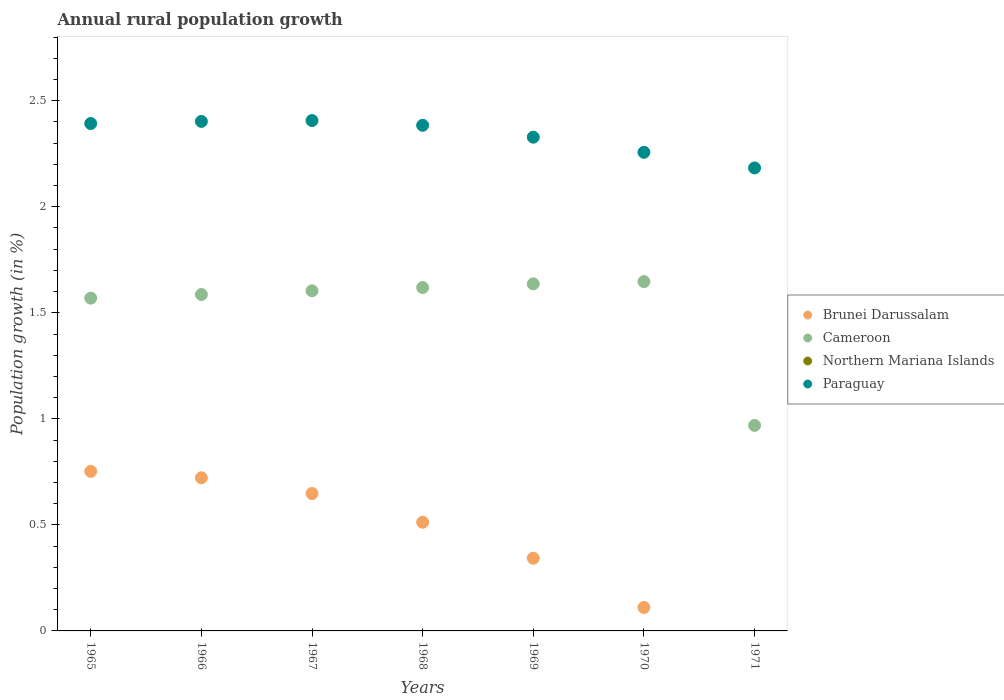How many different coloured dotlines are there?
Make the answer very short. 3. Is the number of dotlines equal to the number of legend labels?
Make the answer very short. No. What is the percentage of rural population growth in Northern Mariana Islands in 1968?
Ensure brevity in your answer.  0. Across all years, what is the maximum percentage of rural population growth in Paraguay?
Your answer should be very brief. 2.41. Across all years, what is the minimum percentage of rural population growth in Cameroon?
Give a very brief answer. 0.97. In which year was the percentage of rural population growth in Paraguay maximum?
Ensure brevity in your answer.  1967. What is the total percentage of rural population growth in Paraguay in the graph?
Ensure brevity in your answer.  16.35. What is the difference between the percentage of rural population growth in Paraguay in 1965 and that in 1971?
Keep it short and to the point. 0.21. What is the difference between the percentage of rural population growth in Paraguay in 1966 and the percentage of rural population growth in Northern Mariana Islands in 1968?
Provide a short and direct response. 2.4. What is the average percentage of rural population growth in Brunei Darussalam per year?
Your answer should be compact. 0.44. In the year 1969, what is the difference between the percentage of rural population growth in Brunei Darussalam and percentage of rural population growth in Cameroon?
Provide a succinct answer. -1.29. In how many years, is the percentage of rural population growth in Northern Mariana Islands greater than 1.7 %?
Give a very brief answer. 0. What is the ratio of the percentage of rural population growth in Paraguay in 1966 to that in 1970?
Keep it short and to the point. 1.06. Is the difference between the percentage of rural population growth in Brunei Darussalam in 1966 and 1970 greater than the difference between the percentage of rural population growth in Cameroon in 1966 and 1970?
Your answer should be very brief. Yes. What is the difference between the highest and the second highest percentage of rural population growth in Paraguay?
Provide a succinct answer. 0. What is the difference between the highest and the lowest percentage of rural population growth in Cameroon?
Your answer should be compact. 0.68. In how many years, is the percentage of rural population growth in Northern Mariana Islands greater than the average percentage of rural population growth in Northern Mariana Islands taken over all years?
Your answer should be compact. 0. Is the sum of the percentage of rural population growth in Paraguay in 1968 and 1971 greater than the maximum percentage of rural population growth in Northern Mariana Islands across all years?
Your response must be concise. Yes. Is it the case that in every year, the sum of the percentage of rural population growth in Brunei Darussalam and percentage of rural population growth in Paraguay  is greater than the sum of percentage of rural population growth in Northern Mariana Islands and percentage of rural population growth in Cameroon?
Ensure brevity in your answer.  No. Is it the case that in every year, the sum of the percentage of rural population growth in Brunei Darussalam and percentage of rural population growth in Paraguay  is greater than the percentage of rural population growth in Cameroon?
Make the answer very short. Yes. Is the percentage of rural population growth in Northern Mariana Islands strictly less than the percentage of rural population growth in Paraguay over the years?
Your answer should be compact. Yes. How many dotlines are there?
Your response must be concise. 3. How many years are there in the graph?
Your response must be concise. 7. What is the difference between two consecutive major ticks on the Y-axis?
Give a very brief answer. 0.5. Are the values on the major ticks of Y-axis written in scientific E-notation?
Offer a terse response. No. Does the graph contain any zero values?
Ensure brevity in your answer.  Yes. Does the graph contain grids?
Ensure brevity in your answer.  No. Where does the legend appear in the graph?
Make the answer very short. Center right. How many legend labels are there?
Provide a succinct answer. 4. How are the legend labels stacked?
Offer a very short reply. Vertical. What is the title of the graph?
Your response must be concise. Annual rural population growth. What is the label or title of the Y-axis?
Provide a short and direct response. Population growth (in %). What is the Population growth (in %) in Brunei Darussalam in 1965?
Your answer should be very brief. 0.75. What is the Population growth (in %) of Cameroon in 1965?
Provide a succinct answer. 1.57. What is the Population growth (in %) in Northern Mariana Islands in 1965?
Offer a terse response. 0. What is the Population growth (in %) of Paraguay in 1965?
Keep it short and to the point. 2.39. What is the Population growth (in %) in Brunei Darussalam in 1966?
Make the answer very short. 0.72. What is the Population growth (in %) of Cameroon in 1966?
Keep it short and to the point. 1.59. What is the Population growth (in %) in Paraguay in 1966?
Your response must be concise. 2.4. What is the Population growth (in %) in Brunei Darussalam in 1967?
Offer a terse response. 0.65. What is the Population growth (in %) in Cameroon in 1967?
Provide a succinct answer. 1.6. What is the Population growth (in %) in Paraguay in 1967?
Offer a terse response. 2.41. What is the Population growth (in %) in Brunei Darussalam in 1968?
Offer a terse response. 0.51. What is the Population growth (in %) in Cameroon in 1968?
Your response must be concise. 1.62. What is the Population growth (in %) of Paraguay in 1968?
Offer a terse response. 2.38. What is the Population growth (in %) of Brunei Darussalam in 1969?
Your answer should be compact. 0.34. What is the Population growth (in %) of Cameroon in 1969?
Offer a terse response. 1.64. What is the Population growth (in %) of Paraguay in 1969?
Keep it short and to the point. 2.33. What is the Population growth (in %) of Brunei Darussalam in 1970?
Provide a succinct answer. 0.11. What is the Population growth (in %) of Cameroon in 1970?
Give a very brief answer. 1.65. What is the Population growth (in %) in Paraguay in 1970?
Provide a short and direct response. 2.26. What is the Population growth (in %) in Cameroon in 1971?
Your answer should be very brief. 0.97. What is the Population growth (in %) of Paraguay in 1971?
Your answer should be compact. 2.18. Across all years, what is the maximum Population growth (in %) in Brunei Darussalam?
Provide a short and direct response. 0.75. Across all years, what is the maximum Population growth (in %) of Cameroon?
Offer a very short reply. 1.65. Across all years, what is the maximum Population growth (in %) in Paraguay?
Provide a succinct answer. 2.41. Across all years, what is the minimum Population growth (in %) of Cameroon?
Your answer should be very brief. 0.97. Across all years, what is the minimum Population growth (in %) of Paraguay?
Your response must be concise. 2.18. What is the total Population growth (in %) in Brunei Darussalam in the graph?
Offer a terse response. 3.09. What is the total Population growth (in %) of Cameroon in the graph?
Provide a succinct answer. 10.63. What is the total Population growth (in %) of Paraguay in the graph?
Offer a terse response. 16.35. What is the difference between the Population growth (in %) in Brunei Darussalam in 1965 and that in 1966?
Provide a short and direct response. 0.03. What is the difference between the Population growth (in %) in Cameroon in 1965 and that in 1966?
Provide a short and direct response. -0.02. What is the difference between the Population growth (in %) of Paraguay in 1965 and that in 1966?
Make the answer very short. -0.01. What is the difference between the Population growth (in %) of Brunei Darussalam in 1965 and that in 1967?
Offer a terse response. 0.1. What is the difference between the Population growth (in %) of Cameroon in 1965 and that in 1967?
Offer a terse response. -0.03. What is the difference between the Population growth (in %) of Paraguay in 1965 and that in 1967?
Your answer should be very brief. -0.01. What is the difference between the Population growth (in %) of Brunei Darussalam in 1965 and that in 1968?
Ensure brevity in your answer.  0.24. What is the difference between the Population growth (in %) of Cameroon in 1965 and that in 1968?
Ensure brevity in your answer.  -0.05. What is the difference between the Population growth (in %) of Paraguay in 1965 and that in 1968?
Provide a succinct answer. 0.01. What is the difference between the Population growth (in %) in Brunei Darussalam in 1965 and that in 1969?
Provide a succinct answer. 0.41. What is the difference between the Population growth (in %) in Cameroon in 1965 and that in 1969?
Your response must be concise. -0.07. What is the difference between the Population growth (in %) of Paraguay in 1965 and that in 1969?
Your response must be concise. 0.06. What is the difference between the Population growth (in %) in Brunei Darussalam in 1965 and that in 1970?
Your answer should be compact. 0.64. What is the difference between the Population growth (in %) in Cameroon in 1965 and that in 1970?
Provide a succinct answer. -0.08. What is the difference between the Population growth (in %) of Paraguay in 1965 and that in 1970?
Provide a short and direct response. 0.14. What is the difference between the Population growth (in %) of Cameroon in 1965 and that in 1971?
Your response must be concise. 0.6. What is the difference between the Population growth (in %) of Paraguay in 1965 and that in 1971?
Provide a succinct answer. 0.21. What is the difference between the Population growth (in %) in Brunei Darussalam in 1966 and that in 1967?
Make the answer very short. 0.07. What is the difference between the Population growth (in %) in Cameroon in 1966 and that in 1967?
Offer a terse response. -0.02. What is the difference between the Population growth (in %) of Paraguay in 1966 and that in 1967?
Your answer should be very brief. -0. What is the difference between the Population growth (in %) of Brunei Darussalam in 1966 and that in 1968?
Your answer should be compact. 0.21. What is the difference between the Population growth (in %) of Cameroon in 1966 and that in 1968?
Keep it short and to the point. -0.03. What is the difference between the Population growth (in %) in Paraguay in 1966 and that in 1968?
Keep it short and to the point. 0.02. What is the difference between the Population growth (in %) of Brunei Darussalam in 1966 and that in 1969?
Offer a very short reply. 0.38. What is the difference between the Population growth (in %) in Cameroon in 1966 and that in 1969?
Your answer should be compact. -0.05. What is the difference between the Population growth (in %) in Paraguay in 1966 and that in 1969?
Your response must be concise. 0.07. What is the difference between the Population growth (in %) in Brunei Darussalam in 1966 and that in 1970?
Provide a short and direct response. 0.61. What is the difference between the Population growth (in %) of Cameroon in 1966 and that in 1970?
Give a very brief answer. -0.06. What is the difference between the Population growth (in %) of Paraguay in 1966 and that in 1970?
Your answer should be very brief. 0.15. What is the difference between the Population growth (in %) of Cameroon in 1966 and that in 1971?
Make the answer very short. 0.62. What is the difference between the Population growth (in %) of Paraguay in 1966 and that in 1971?
Your answer should be very brief. 0.22. What is the difference between the Population growth (in %) of Brunei Darussalam in 1967 and that in 1968?
Provide a short and direct response. 0.14. What is the difference between the Population growth (in %) in Cameroon in 1967 and that in 1968?
Give a very brief answer. -0.02. What is the difference between the Population growth (in %) of Paraguay in 1967 and that in 1968?
Offer a terse response. 0.02. What is the difference between the Population growth (in %) of Brunei Darussalam in 1967 and that in 1969?
Provide a succinct answer. 0.3. What is the difference between the Population growth (in %) in Cameroon in 1967 and that in 1969?
Ensure brevity in your answer.  -0.03. What is the difference between the Population growth (in %) of Paraguay in 1967 and that in 1969?
Give a very brief answer. 0.08. What is the difference between the Population growth (in %) in Brunei Darussalam in 1967 and that in 1970?
Provide a short and direct response. 0.54. What is the difference between the Population growth (in %) in Cameroon in 1967 and that in 1970?
Provide a succinct answer. -0.04. What is the difference between the Population growth (in %) in Paraguay in 1967 and that in 1970?
Your answer should be very brief. 0.15. What is the difference between the Population growth (in %) in Cameroon in 1967 and that in 1971?
Make the answer very short. 0.63. What is the difference between the Population growth (in %) of Paraguay in 1967 and that in 1971?
Offer a terse response. 0.22. What is the difference between the Population growth (in %) of Brunei Darussalam in 1968 and that in 1969?
Ensure brevity in your answer.  0.17. What is the difference between the Population growth (in %) in Cameroon in 1968 and that in 1969?
Make the answer very short. -0.02. What is the difference between the Population growth (in %) in Paraguay in 1968 and that in 1969?
Your response must be concise. 0.06. What is the difference between the Population growth (in %) in Brunei Darussalam in 1968 and that in 1970?
Offer a very short reply. 0.4. What is the difference between the Population growth (in %) of Cameroon in 1968 and that in 1970?
Provide a succinct answer. -0.03. What is the difference between the Population growth (in %) of Paraguay in 1968 and that in 1970?
Your answer should be very brief. 0.13. What is the difference between the Population growth (in %) in Cameroon in 1968 and that in 1971?
Keep it short and to the point. 0.65. What is the difference between the Population growth (in %) in Paraguay in 1968 and that in 1971?
Ensure brevity in your answer.  0.2. What is the difference between the Population growth (in %) in Brunei Darussalam in 1969 and that in 1970?
Give a very brief answer. 0.23. What is the difference between the Population growth (in %) in Cameroon in 1969 and that in 1970?
Your answer should be very brief. -0.01. What is the difference between the Population growth (in %) of Paraguay in 1969 and that in 1970?
Your answer should be very brief. 0.07. What is the difference between the Population growth (in %) of Cameroon in 1969 and that in 1971?
Keep it short and to the point. 0.67. What is the difference between the Population growth (in %) of Paraguay in 1969 and that in 1971?
Give a very brief answer. 0.14. What is the difference between the Population growth (in %) in Cameroon in 1970 and that in 1971?
Ensure brevity in your answer.  0.68. What is the difference between the Population growth (in %) of Paraguay in 1970 and that in 1971?
Provide a succinct answer. 0.07. What is the difference between the Population growth (in %) in Brunei Darussalam in 1965 and the Population growth (in %) in Cameroon in 1966?
Give a very brief answer. -0.83. What is the difference between the Population growth (in %) in Brunei Darussalam in 1965 and the Population growth (in %) in Paraguay in 1966?
Provide a succinct answer. -1.65. What is the difference between the Population growth (in %) in Cameroon in 1965 and the Population growth (in %) in Paraguay in 1966?
Keep it short and to the point. -0.83. What is the difference between the Population growth (in %) of Brunei Darussalam in 1965 and the Population growth (in %) of Cameroon in 1967?
Give a very brief answer. -0.85. What is the difference between the Population growth (in %) of Brunei Darussalam in 1965 and the Population growth (in %) of Paraguay in 1967?
Offer a terse response. -1.65. What is the difference between the Population growth (in %) of Cameroon in 1965 and the Population growth (in %) of Paraguay in 1967?
Provide a short and direct response. -0.84. What is the difference between the Population growth (in %) of Brunei Darussalam in 1965 and the Population growth (in %) of Cameroon in 1968?
Your response must be concise. -0.87. What is the difference between the Population growth (in %) of Brunei Darussalam in 1965 and the Population growth (in %) of Paraguay in 1968?
Make the answer very short. -1.63. What is the difference between the Population growth (in %) of Cameroon in 1965 and the Population growth (in %) of Paraguay in 1968?
Offer a very short reply. -0.81. What is the difference between the Population growth (in %) of Brunei Darussalam in 1965 and the Population growth (in %) of Cameroon in 1969?
Your answer should be very brief. -0.88. What is the difference between the Population growth (in %) in Brunei Darussalam in 1965 and the Population growth (in %) in Paraguay in 1969?
Provide a short and direct response. -1.58. What is the difference between the Population growth (in %) of Cameroon in 1965 and the Population growth (in %) of Paraguay in 1969?
Your answer should be compact. -0.76. What is the difference between the Population growth (in %) in Brunei Darussalam in 1965 and the Population growth (in %) in Cameroon in 1970?
Provide a succinct answer. -0.89. What is the difference between the Population growth (in %) in Brunei Darussalam in 1965 and the Population growth (in %) in Paraguay in 1970?
Your answer should be very brief. -1.5. What is the difference between the Population growth (in %) of Cameroon in 1965 and the Population growth (in %) of Paraguay in 1970?
Offer a terse response. -0.69. What is the difference between the Population growth (in %) in Brunei Darussalam in 1965 and the Population growth (in %) in Cameroon in 1971?
Provide a short and direct response. -0.22. What is the difference between the Population growth (in %) of Brunei Darussalam in 1965 and the Population growth (in %) of Paraguay in 1971?
Your answer should be very brief. -1.43. What is the difference between the Population growth (in %) in Cameroon in 1965 and the Population growth (in %) in Paraguay in 1971?
Your answer should be compact. -0.61. What is the difference between the Population growth (in %) in Brunei Darussalam in 1966 and the Population growth (in %) in Cameroon in 1967?
Offer a very short reply. -0.88. What is the difference between the Population growth (in %) of Brunei Darussalam in 1966 and the Population growth (in %) of Paraguay in 1967?
Provide a succinct answer. -1.68. What is the difference between the Population growth (in %) in Cameroon in 1966 and the Population growth (in %) in Paraguay in 1967?
Offer a terse response. -0.82. What is the difference between the Population growth (in %) in Brunei Darussalam in 1966 and the Population growth (in %) in Cameroon in 1968?
Offer a very short reply. -0.9. What is the difference between the Population growth (in %) of Brunei Darussalam in 1966 and the Population growth (in %) of Paraguay in 1968?
Keep it short and to the point. -1.66. What is the difference between the Population growth (in %) of Cameroon in 1966 and the Population growth (in %) of Paraguay in 1968?
Your response must be concise. -0.8. What is the difference between the Population growth (in %) of Brunei Darussalam in 1966 and the Population growth (in %) of Cameroon in 1969?
Make the answer very short. -0.91. What is the difference between the Population growth (in %) of Brunei Darussalam in 1966 and the Population growth (in %) of Paraguay in 1969?
Your answer should be compact. -1.61. What is the difference between the Population growth (in %) in Cameroon in 1966 and the Population growth (in %) in Paraguay in 1969?
Provide a short and direct response. -0.74. What is the difference between the Population growth (in %) of Brunei Darussalam in 1966 and the Population growth (in %) of Cameroon in 1970?
Your answer should be very brief. -0.93. What is the difference between the Population growth (in %) in Brunei Darussalam in 1966 and the Population growth (in %) in Paraguay in 1970?
Your response must be concise. -1.53. What is the difference between the Population growth (in %) of Cameroon in 1966 and the Population growth (in %) of Paraguay in 1970?
Ensure brevity in your answer.  -0.67. What is the difference between the Population growth (in %) of Brunei Darussalam in 1966 and the Population growth (in %) of Cameroon in 1971?
Give a very brief answer. -0.25. What is the difference between the Population growth (in %) of Brunei Darussalam in 1966 and the Population growth (in %) of Paraguay in 1971?
Ensure brevity in your answer.  -1.46. What is the difference between the Population growth (in %) in Cameroon in 1966 and the Population growth (in %) in Paraguay in 1971?
Keep it short and to the point. -0.6. What is the difference between the Population growth (in %) of Brunei Darussalam in 1967 and the Population growth (in %) of Cameroon in 1968?
Keep it short and to the point. -0.97. What is the difference between the Population growth (in %) of Brunei Darussalam in 1967 and the Population growth (in %) of Paraguay in 1968?
Offer a very short reply. -1.74. What is the difference between the Population growth (in %) in Cameroon in 1967 and the Population growth (in %) in Paraguay in 1968?
Your response must be concise. -0.78. What is the difference between the Population growth (in %) of Brunei Darussalam in 1967 and the Population growth (in %) of Cameroon in 1969?
Offer a very short reply. -0.99. What is the difference between the Population growth (in %) in Brunei Darussalam in 1967 and the Population growth (in %) in Paraguay in 1969?
Your response must be concise. -1.68. What is the difference between the Population growth (in %) of Cameroon in 1967 and the Population growth (in %) of Paraguay in 1969?
Ensure brevity in your answer.  -0.72. What is the difference between the Population growth (in %) in Brunei Darussalam in 1967 and the Population growth (in %) in Cameroon in 1970?
Your response must be concise. -1. What is the difference between the Population growth (in %) of Brunei Darussalam in 1967 and the Population growth (in %) of Paraguay in 1970?
Your response must be concise. -1.61. What is the difference between the Population growth (in %) in Cameroon in 1967 and the Population growth (in %) in Paraguay in 1970?
Offer a very short reply. -0.65. What is the difference between the Population growth (in %) of Brunei Darussalam in 1967 and the Population growth (in %) of Cameroon in 1971?
Provide a succinct answer. -0.32. What is the difference between the Population growth (in %) in Brunei Darussalam in 1967 and the Population growth (in %) in Paraguay in 1971?
Offer a very short reply. -1.54. What is the difference between the Population growth (in %) of Cameroon in 1967 and the Population growth (in %) of Paraguay in 1971?
Your response must be concise. -0.58. What is the difference between the Population growth (in %) of Brunei Darussalam in 1968 and the Population growth (in %) of Cameroon in 1969?
Provide a short and direct response. -1.12. What is the difference between the Population growth (in %) in Brunei Darussalam in 1968 and the Population growth (in %) in Paraguay in 1969?
Keep it short and to the point. -1.82. What is the difference between the Population growth (in %) of Cameroon in 1968 and the Population growth (in %) of Paraguay in 1969?
Keep it short and to the point. -0.71. What is the difference between the Population growth (in %) in Brunei Darussalam in 1968 and the Population growth (in %) in Cameroon in 1970?
Offer a terse response. -1.13. What is the difference between the Population growth (in %) of Brunei Darussalam in 1968 and the Population growth (in %) of Paraguay in 1970?
Provide a short and direct response. -1.74. What is the difference between the Population growth (in %) of Cameroon in 1968 and the Population growth (in %) of Paraguay in 1970?
Your answer should be compact. -0.64. What is the difference between the Population growth (in %) of Brunei Darussalam in 1968 and the Population growth (in %) of Cameroon in 1971?
Ensure brevity in your answer.  -0.46. What is the difference between the Population growth (in %) in Brunei Darussalam in 1968 and the Population growth (in %) in Paraguay in 1971?
Ensure brevity in your answer.  -1.67. What is the difference between the Population growth (in %) of Cameroon in 1968 and the Population growth (in %) of Paraguay in 1971?
Provide a short and direct response. -0.56. What is the difference between the Population growth (in %) of Brunei Darussalam in 1969 and the Population growth (in %) of Cameroon in 1970?
Your answer should be compact. -1.3. What is the difference between the Population growth (in %) in Brunei Darussalam in 1969 and the Population growth (in %) in Paraguay in 1970?
Keep it short and to the point. -1.91. What is the difference between the Population growth (in %) of Cameroon in 1969 and the Population growth (in %) of Paraguay in 1970?
Make the answer very short. -0.62. What is the difference between the Population growth (in %) in Brunei Darussalam in 1969 and the Population growth (in %) in Cameroon in 1971?
Your answer should be compact. -0.63. What is the difference between the Population growth (in %) in Brunei Darussalam in 1969 and the Population growth (in %) in Paraguay in 1971?
Offer a very short reply. -1.84. What is the difference between the Population growth (in %) of Cameroon in 1969 and the Population growth (in %) of Paraguay in 1971?
Provide a short and direct response. -0.55. What is the difference between the Population growth (in %) of Brunei Darussalam in 1970 and the Population growth (in %) of Cameroon in 1971?
Provide a succinct answer. -0.86. What is the difference between the Population growth (in %) in Brunei Darussalam in 1970 and the Population growth (in %) in Paraguay in 1971?
Keep it short and to the point. -2.07. What is the difference between the Population growth (in %) in Cameroon in 1970 and the Population growth (in %) in Paraguay in 1971?
Ensure brevity in your answer.  -0.54. What is the average Population growth (in %) in Brunei Darussalam per year?
Ensure brevity in your answer.  0.44. What is the average Population growth (in %) of Cameroon per year?
Offer a very short reply. 1.52. What is the average Population growth (in %) of Paraguay per year?
Provide a succinct answer. 2.34. In the year 1965, what is the difference between the Population growth (in %) of Brunei Darussalam and Population growth (in %) of Cameroon?
Provide a short and direct response. -0.82. In the year 1965, what is the difference between the Population growth (in %) of Brunei Darussalam and Population growth (in %) of Paraguay?
Make the answer very short. -1.64. In the year 1965, what is the difference between the Population growth (in %) in Cameroon and Population growth (in %) in Paraguay?
Offer a very short reply. -0.82. In the year 1966, what is the difference between the Population growth (in %) in Brunei Darussalam and Population growth (in %) in Cameroon?
Your answer should be very brief. -0.86. In the year 1966, what is the difference between the Population growth (in %) in Brunei Darussalam and Population growth (in %) in Paraguay?
Ensure brevity in your answer.  -1.68. In the year 1966, what is the difference between the Population growth (in %) in Cameroon and Population growth (in %) in Paraguay?
Ensure brevity in your answer.  -0.82. In the year 1967, what is the difference between the Population growth (in %) in Brunei Darussalam and Population growth (in %) in Cameroon?
Keep it short and to the point. -0.96. In the year 1967, what is the difference between the Population growth (in %) in Brunei Darussalam and Population growth (in %) in Paraguay?
Give a very brief answer. -1.76. In the year 1967, what is the difference between the Population growth (in %) in Cameroon and Population growth (in %) in Paraguay?
Make the answer very short. -0.8. In the year 1968, what is the difference between the Population growth (in %) in Brunei Darussalam and Population growth (in %) in Cameroon?
Provide a succinct answer. -1.11. In the year 1968, what is the difference between the Population growth (in %) in Brunei Darussalam and Population growth (in %) in Paraguay?
Offer a terse response. -1.87. In the year 1968, what is the difference between the Population growth (in %) of Cameroon and Population growth (in %) of Paraguay?
Provide a succinct answer. -0.77. In the year 1969, what is the difference between the Population growth (in %) of Brunei Darussalam and Population growth (in %) of Cameroon?
Offer a terse response. -1.29. In the year 1969, what is the difference between the Population growth (in %) in Brunei Darussalam and Population growth (in %) in Paraguay?
Offer a terse response. -1.99. In the year 1969, what is the difference between the Population growth (in %) of Cameroon and Population growth (in %) of Paraguay?
Offer a terse response. -0.69. In the year 1970, what is the difference between the Population growth (in %) in Brunei Darussalam and Population growth (in %) in Cameroon?
Your response must be concise. -1.54. In the year 1970, what is the difference between the Population growth (in %) in Brunei Darussalam and Population growth (in %) in Paraguay?
Your answer should be very brief. -2.15. In the year 1970, what is the difference between the Population growth (in %) in Cameroon and Population growth (in %) in Paraguay?
Give a very brief answer. -0.61. In the year 1971, what is the difference between the Population growth (in %) of Cameroon and Population growth (in %) of Paraguay?
Provide a succinct answer. -1.21. What is the ratio of the Population growth (in %) of Brunei Darussalam in 1965 to that in 1966?
Offer a terse response. 1.04. What is the ratio of the Population growth (in %) of Brunei Darussalam in 1965 to that in 1967?
Provide a succinct answer. 1.16. What is the ratio of the Population growth (in %) in Cameroon in 1965 to that in 1967?
Provide a short and direct response. 0.98. What is the ratio of the Population growth (in %) of Paraguay in 1965 to that in 1967?
Your answer should be very brief. 0.99. What is the ratio of the Population growth (in %) of Brunei Darussalam in 1965 to that in 1968?
Provide a succinct answer. 1.47. What is the ratio of the Population growth (in %) in Cameroon in 1965 to that in 1968?
Give a very brief answer. 0.97. What is the ratio of the Population growth (in %) of Brunei Darussalam in 1965 to that in 1969?
Provide a short and direct response. 2.19. What is the ratio of the Population growth (in %) in Cameroon in 1965 to that in 1969?
Give a very brief answer. 0.96. What is the ratio of the Population growth (in %) of Paraguay in 1965 to that in 1969?
Your answer should be compact. 1.03. What is the ratio of the Population growth (in %) of Brunei Darussalam in 1965 to that in 1970?
Give a very brief answer. 6.8. What is the ratio of the Population growth (in %) in Cameroon in 1965 to that in 1970?
Make the answer very short. 0.95. What is the ratio of the Population growth (in %) in Paraguay in 1965 to that in 1970?
Ensure brevity in your answer.  1.06. What is the ratio of the Population growth (in %) of Cameroon in 1965 to that in 1971?
Your response must be concise. 1.62. What is the ratio of the Population growth (in %) in Paraguay in 1965 to that in 1971?
Provide a succinct answer. 1.1. What is the ratio of the Population growth (in %) of Brunei Darussalam in 1966 to that in 1967?
Give a very brief answer. 1.11. What is the ratio of the Population growth (in %) of Cameroon in 1966 to that in 1967?
Provide a short and direct response. 0.99. What is the ratio of the Population growth (in %) in Paraguay in 1966 to that in 1967?
Offer a very short reply. 1. What is the ratio of the Population growth (in %) in Brunei Darussalam in 1966 to that in 1968?
Ensure brevity in your answer.  1.41. What is the ratio of the Population growth (in %) of Cameroon in 1966 to that in 1968?
Offer a terse response. 0.98. What is the ratio of the Population growth (in %) in Paraguay in 1966 to that in 1968?
Your response must be concise. 1.01. What is the ratio of the Population growth (in %) in Brunei Darussalam in 1966 to that in 1969?
Make the answer very short. 2.11. What is the ratio of the Population growth (in %) of Cameroon in 1966 to that in 1969?
Provide a short and direct response. 0.97. What is the ratio of the Population growth (in %) in Paraguay in 1966 to that in 1969?
Provide a short and direct response. 1.03. What is the ratio of the Population growth (in %) of Brunei Darussalam in 1966 to that in 1970?
Your answer should be very brief. 6.52. What is the ratio of the Population growth (in %) in Cameroon in 1966 to that in 1970?
Provide a short and direct response. 0.96. What is the ratio of the Population growth (in %) of Paraguay in 1966 to that in 1970?
Your answer should be very brief. 1.06. What is the ratio of the Population growth (in %) in Cameroon in 1966 to that in 1971?
Give a very brief answer. 1.64. What is the ratio of the Population growth (in %) of Paraguay in 1966 to that in 1971?
Your answer should be very brief. 1.1. What is the ratio of the Population growth (in %) in Brunei Darussalam in 1967 to that in 1968?
Offer a terse response. 1.26. What is the ratio of the Population growth (in %) of Cameroon in 1967 to that in 1968?
Your response must be concise. 0.99. What is the ratio of the Population growth (in %) in Paraguay in 1967 to that in 1968?
Keep it short and to the point. 1.01. What is the ratio of the Population growth (in %) of Brunei Darussalam in 1967 to that in 1969?
Ensure brevity in your answer.  1.89. What is the ratio of the Population growth (in %) in Cameroon in 1967 to that in 1969?
Your answer should be very brief. 0.98. What is the ratio of the Population growth (in %) of Paraguay in 1967 to that in 1969?
Your response must be concise. 1.03. What is the ratio of the Population growth (in %) of Brunei Darussalam in 1967 to that in 1970?
Your answer should be compact. 5.85. What is the ratio of the Population growth (in %) of Cameroon in 1967 to that in 1970?
Provide a succinct answer. 0.97. What is the ratio of the Population growth (in %) of Paraguay in 1967 to that in 1970?
Make the answer very short. 1.07. What is the ratio of the Population growth (in %) in Cameroon in 1967 to that in 1971?
Ensure brevity in your answer.  1.65. What is the ratio of the Population growth (in %) of Paraguay in 1967 to that in 1971?
Offer a very short reply. 1.1. What is the ratio of the Population growth (in %) of Brunei Darussalam in 1968 to that in 1969?
Offer a very short reply. 1.49. What is the ratio of the Population growth (in %) in Paraguay in 1968 to that in 1969?
Your answer should be compact. 1.02. What is the ratio of the Population growth (in %) in Brunei Darussalam in 1968 to that in 1970?
Provide a short and direct response. 4.63. What is the ratio of the Population growth (in %) of Cameroon in 1968 to that in 1970?
Give a very brief answer. 0.98. What is the ratio of the Population growth (in %) in Paraguay in 1968 to that in 1970?
Give a very brief answer. 1.06. What is the ratio of the Population growth (in %) of Cameroon in 1968 to that in 1971?
Keep it short and to the point. 1.67. What is the ratio of the Population growth (in %) in Paraguay in 1968 to that in 1971?
Offer a very short reply. 1.09. What is the ratio of the Population growth (in %) of Brunei Darussalam in 1969 to that in 1970?
Your answer should be compact. 3.1. What is the ratio of the Population growth (in %) in Cameroon in 1969 to that in 1970?
Offer a very short reply. 0.99. What is the ratio of the Population growth (in %) of Paraguay in 1969 to that in 1970?
Your answer should be compact. 1.03. What is the ratio of the Population growth (in %) in Cameroon in 1969 to that in 1971?
Your answer should be very brief. 1.69. What is the ratio of the Population growth (in %) in Paraguay in 1969 to that in 1971?
Keep it short and to the point. 1.07. What is the ratio of the Population growth (in %) of Cameroon in 1970 to that in 1971?
Make the answer very short. 1.7. What is the ratio of the Population growth (in %) of Paraguay in 1970 to that in 1971?
Provide a short and direct response. 1.03. What is the difference between the highest and the second highest Population growth (in %) of Brunei Darussalam?
Keep it short and to the point. 0.03. What is the difference between the highest and the second highest Population growth (in %) of Cameroon?
Provide a short and direct response. 0.01. What is the difference between the highest and the second highest Population growth (in %) in Paraguay?
Provide a succinct answer. 0. What is the difference between the highest and the lowest Population growth (in %) of Brunei Darussalam?
Offer a very short reply. 0.75. What is the difference between the highest and the lowest Population growth (in %) of Cameroon?
Your answer should be very brief. 0.68. What is the difference between the highest and the lowest Population growth (in %) of Paraguay?
Offer a terse response. 0.22. 